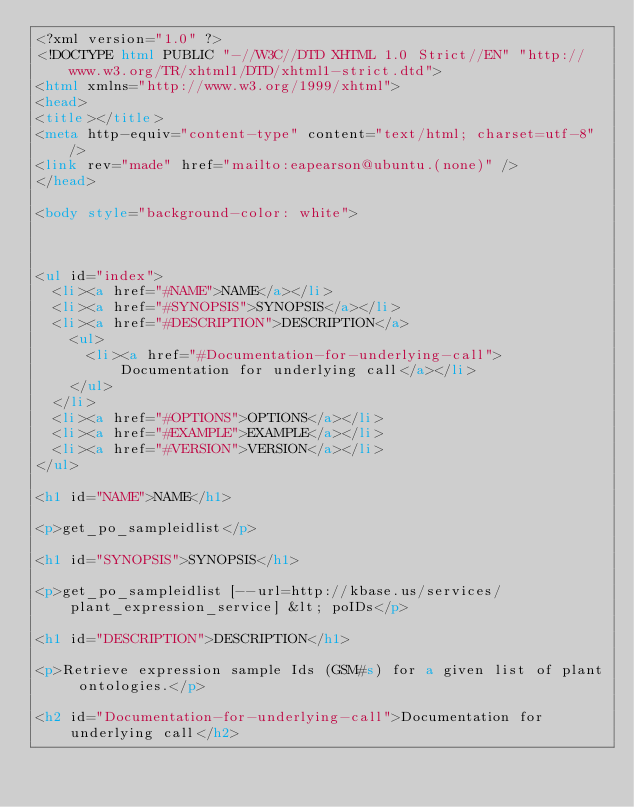<code> <loc_0><loc_0><loc_500><loc_500><_HTML_><?xml version="1.0" ?>
<!DOCTYPE html PUBLIC "-//W3C//DTD XHTML 1.0 Strict//EN" "http://www.w3.org/TR/xhtml1/DTD/xhtml1-strict.dtd">
<html xmlns="http://www.w3.org/1999/xhtml">
<head>
<title></title>
<meta http-equiv="content-type" content="text/html; charset=utf-8" />
<link rev="made" href="mailto:eapearson@ubuntu.(none)" />
</head>

<body style="background-color: white">



<ul id="index">
  <li><a href="#NAME">NAME</a></li>
  <li><a href="#SYNOPSIS">SYNOPSIS</a></li>
  <li><a href="#DESCRIPTION">DESCRIPTION</a>
    <ul>
      <li><a href="#Documentation-for-underlying-call">Documentation for underlying call</a></li>
    </ul>
  </li>
  <li><a href="#OPTIONS">OPTIONS</a></li>
  <li><a href="#EXAMPLE">EXAMPLE</a></li>
  <li><a href="#VERSION">VERSION</a></li>
</ul>

<h1 id="NAME">NAME</h1>

<p>get_po_sampleidlist</p>

<h1 id="SYNOPSIS">SYNOPSIS</h1>

<p>get_po_sampleidlist [--url=http://kbase.us/services/plant_expression_service] &lt; poIDs</p>

<h1 id="DESCRIPTION">DESCRIPTION</h1>

<p>Retrieve expression sample Ids (GSM#s) for a given list of plant ontologies.</p>

<h2 id="Documentation-for-underlying-call">Documentation for underlying call</h2>
</code> 